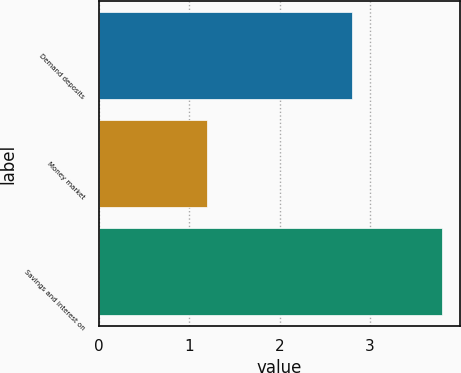Convert chart. <chart><loc_0><loc_0><loc_500><loc_500><bar_chart><fcel>Demand deposits<fcel>Money market<fcel>Savings and interest on<nl><fcel>2.8<fcel>1.2<fcel>3.8<nl></chart> 